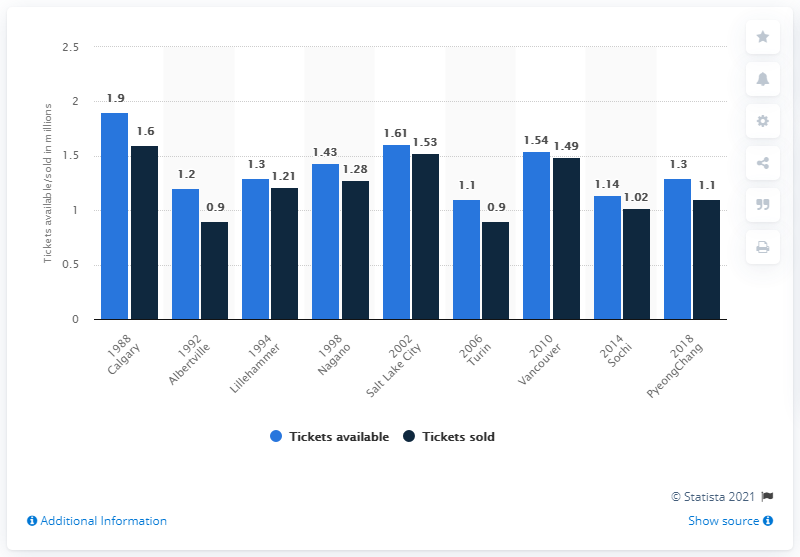Draw attention to some important aspects in this diagram. In 1988, a total of 1.9 million Olympic Winter Games tickets were available for purchase. In 1988, a total of 1,610,000 Olympic Winter Games tickets were sold. The difference between the highest ticket sold and lowest ticket available over the years is 0.5. The highest number of tickets sold was in the year 1988. 